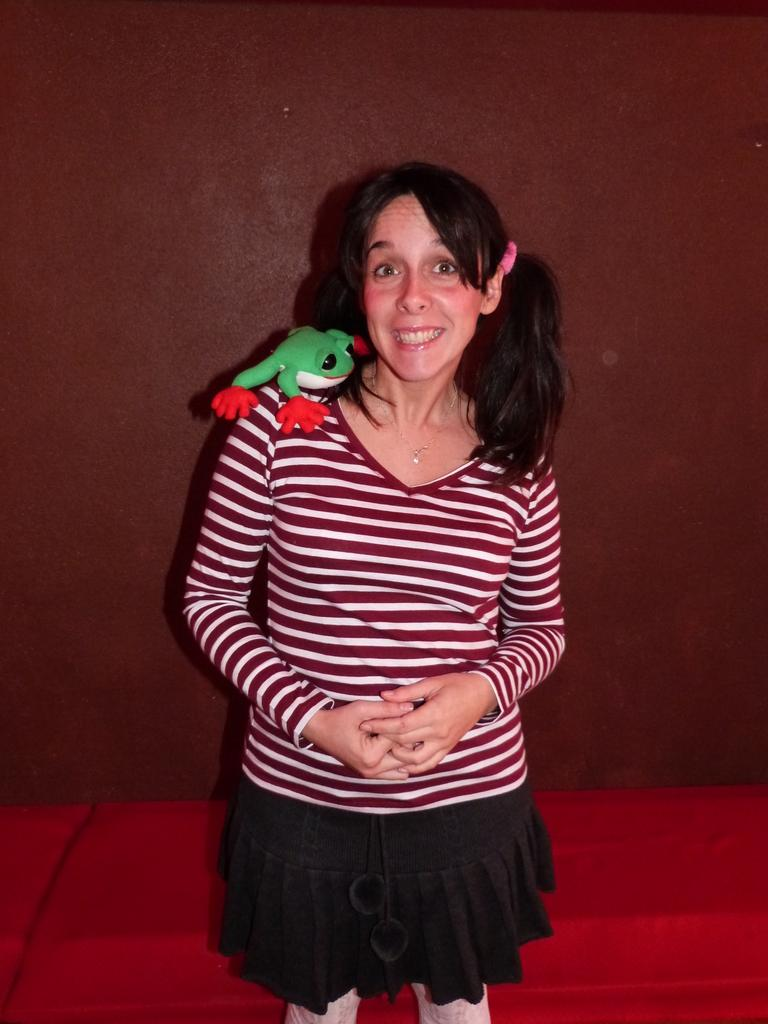What is the main subject of the image? There is a woman standing in the middle of the image. What is on the woman's shoulders? A frog toy is present on the woman's shoulders. What can be seen in the background of the image? There is a wall in the background of the image. What type of screw is visible on the wall in the image? There is no screw visible on the wall in the image. 